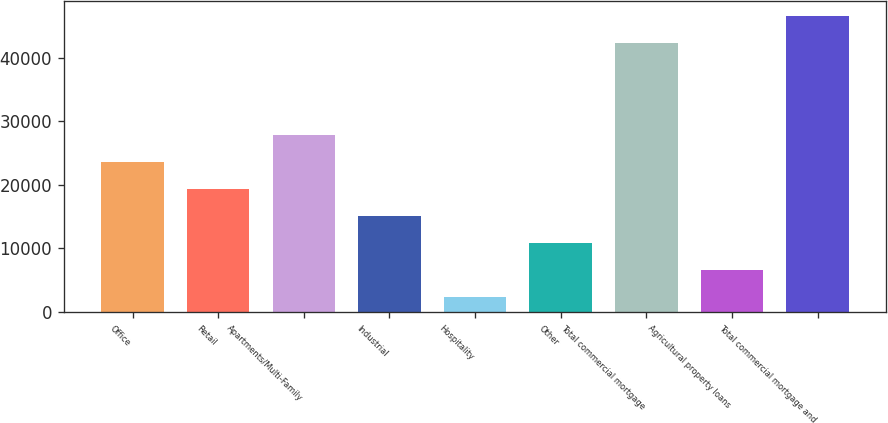<chart> <loc_0><loc_0><loc_500><loc_500><bar_chart><fcel>Office<fcel>Retail<fcel>Apartments/Multi-Family<fcel>Industrial<fcel>Hospitality<fcel>Other<fcel>Total commercial mortgage<fcel>Agricultural property loans<fcel>Total commercial mortgage and<nl><fcel>23509<fcel>19261.2<fcel>27756.8<fcel>15013.4<fcel>2270<fcel>10765.6<fcel>42303<fcel>6517.8<fcel>46550.8<nl></chart> 